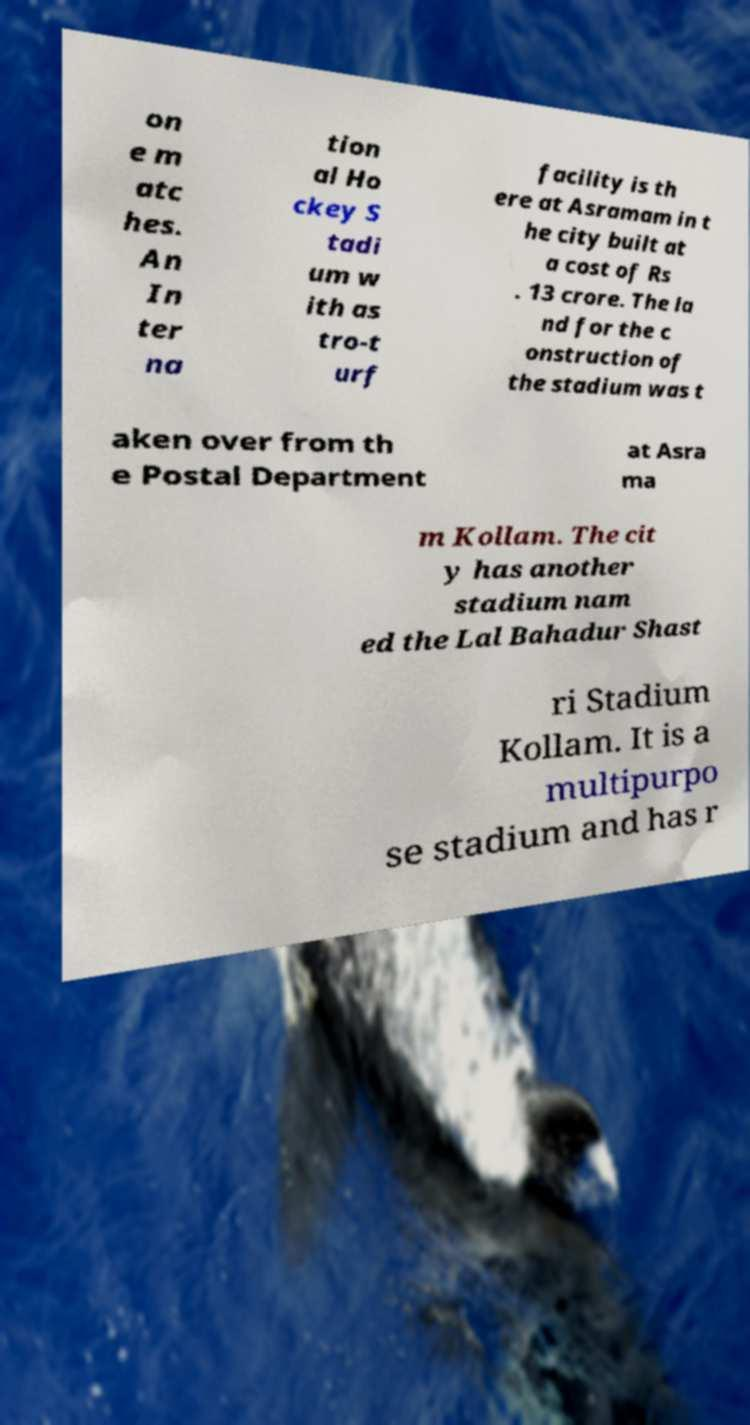What messages or text are displayed in this image? I need them in a readable, typed format. on e m atc hes. An In ter na tion al Ho ckey S tadi um w ith as tro-t urf facility is th ere at Asramam in t he city built at a cost of Rs . 13 crore. The la nd for the c onstruction of the stadium was t aken over from th e Postal Department at Asra ma m Kollam. The cit y has another stadium nam ed the Lal Bahadur Shast ri Stadium Kollam. It is a multipurpo se stadium and has r 